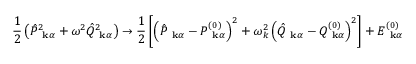Convert formula to latex. <formula><loc_0><loc_0><loc_500><loc_500>\frac { 1 } { 2 } \left ( \hat { P } _ { k \alpha } ^ { 2 } + \omega ^ { 2 } \hat { Q } _ { k \alpha } ^ { 2 } \right ) \to \frac { 1 } { 2 } \left [ \left ( \hat { P } _ { k \alpha } - P _ { k \alpha } ^ { ( 0 ) } \right ) ^ { 2 } + \omega _ { k } ^ { 2 } \left ( \hat { Q } _ { k \alpha } - Q _ { k \alpha } ^ { ( 0 ) } \right ) ^ { 2 } \right ] + E _ { k \alpha } ^ { ( 0 ) }</formula> 